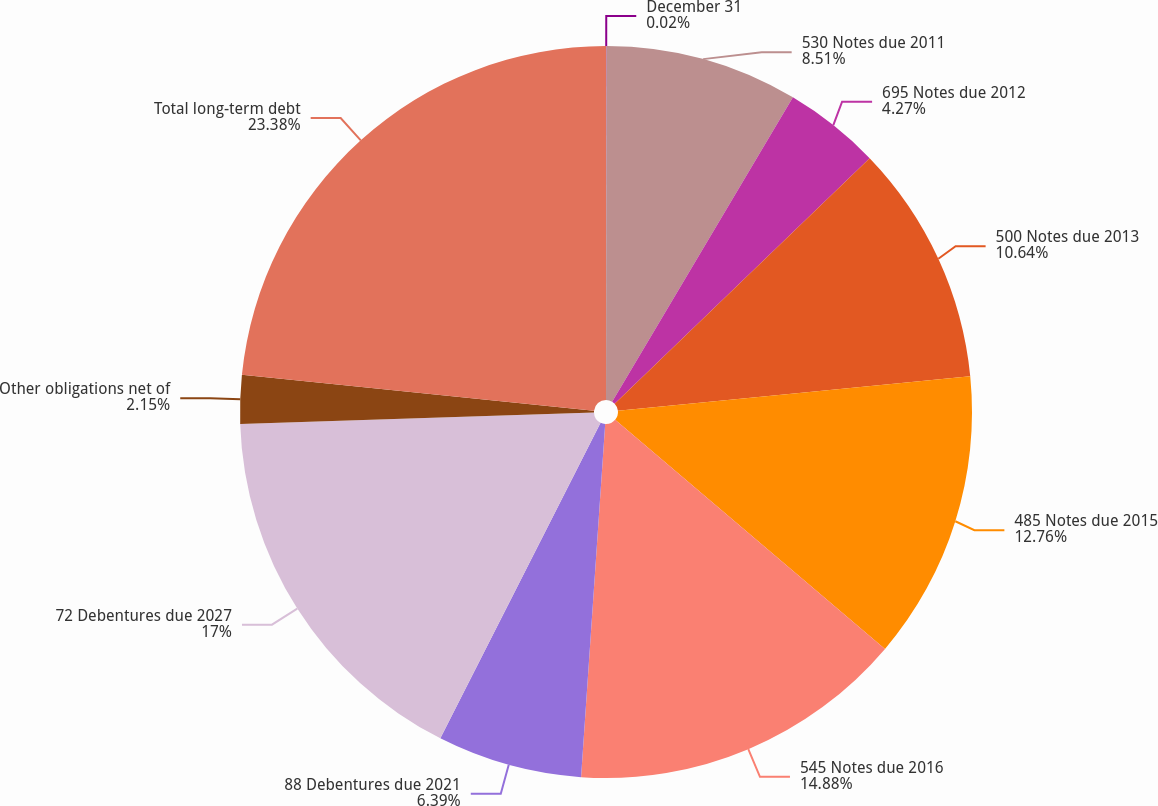<chart> <loc_0><loc_0><loc_500><loc_500><pie_chart><fcel>December 31<fcel>530 Notes due 2011<fcel>695 Notes due 2012<fcel>500 Notes due 2013<fcel>485 Notes due 2015<fcel>545 Notes due 2016<fcel>88 Debentures due 2021<fcel>72 Debentures due 2027<fcel>Other obligations net of<fcel>Total long-term debt<nl><fcel>0.02%<fcel>8.51%<fcel>4.27%<fcel>10.64%<fcel>12.76%<fcel>14.88%<fcel>6.39%<fcel>17.0%<fcel>2.15%<fcel>23.37%<nl></chart> 